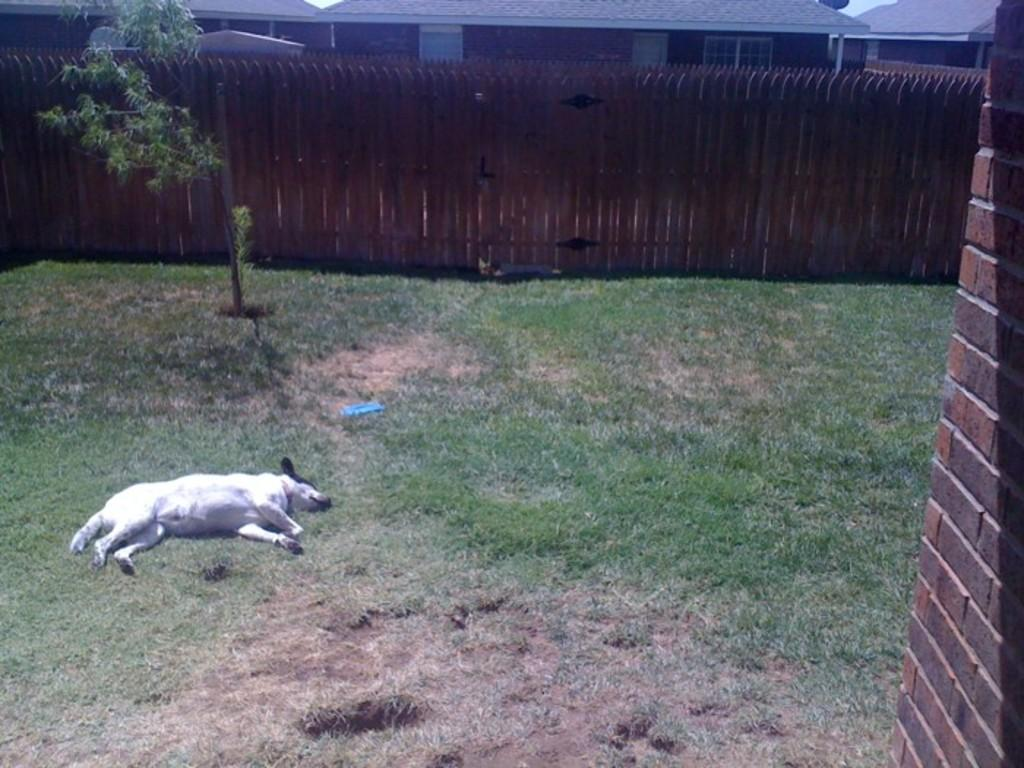What animal can be seen in the image? There is a dog lying on the ground in the image. What type of barrier is present in the image? There is a fence in the image. What type of structure is visible in the image? There is a wall in the image. What can be seen in the distance in the image? There are houses visible in the background of the image. What type of liquid is being poured on the dog in the image? There is no liquid being poured on the dog in the image; the dog is simply lying on the ground. 